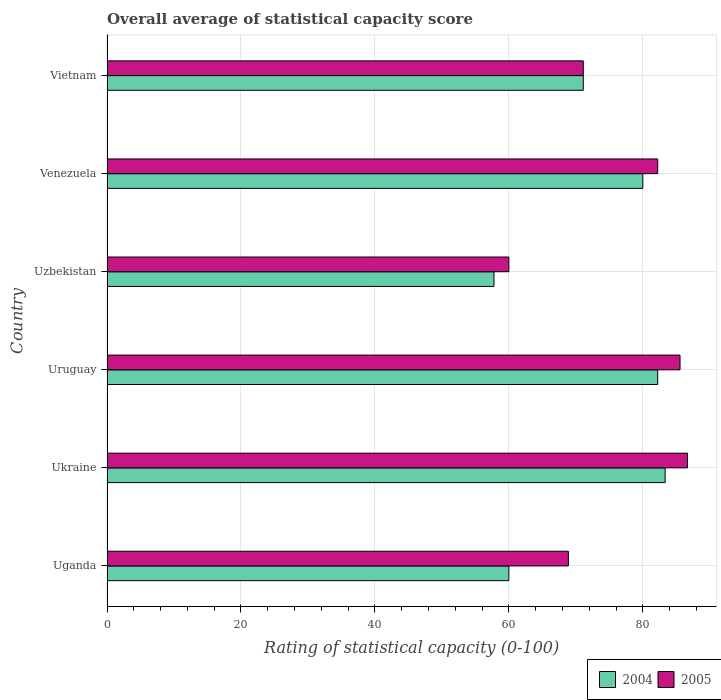Are the number of bars on each tick of the Y-axis equal?
Your answer should be very brief. Yes. How many bars are there on the 5th tick from the top?
Provide a succinct answer. 2. How many bars are there on the 2nd tick from the bottom?
Your answer should be compact. 2. What is the label of the 5th group of bars from the top?
Keep it short and to the point. Ukraine. What is the rating of statistical capacity in 2005 in Ukraine?
Offer a terse response. 86.67. Across all countries, what is the maximum rating of statistical capacity in 2004?
Make the answer very short. 83.33. In which country was the rating of statistical capacity in 2004 maximum?
Provide a succinct answer. Ukraine. In which country was the rating of statistical capacity in 2005 minimum?
Provide a short and direct response. Uzbekistan. What is the total rating of statistical capacity in 2004 in the graph?
Make the answer very short. 434.44. What is the difference between the rating of statistical capacity in 2004 in Venezuela and that in Vietnam?
Your answer should be very brief. 8.89. What is the average rating of statistical capacity in 2004 per country?
Give a very brief answer. 72.41. What is the difference between the rating of statistical capacity in 2005 and rating of statistical capacity in 2004 in Uzbekistan?
Your answer should be very brief. 2.22. What is the ratio of the rating of statistical capacity in 2005 in Ukraine to that in Venezuela?
Ensure brevity in your answer.  1.05. Is the rating of statistical capacity in 2004 in Uganda less than that in Venezuela?
Provide a succinct answer. Yes. What is the difference between the highest and the second highest rating of statistical capacity in 2005?
Give a very brief answer. 1.11. What is the difference between the highest and the lowest rating of statistical capacity in 2005?
Give a very brief answer. 26.67. Is the sum of the rating of statistical capacity in 2005 in Uruguay and Vietnam greater than the maximum rating of statistical capacity in 2004 across all countries?
Your answer should be compact. Yes. What does the 2nd bar from the top in Venezuela represents?
Provide a short and direct response. 2004. What does the 2nd bar from the bottom in Uzbekistan represents?
Your response must be concise. 2005. How many bars are there?
Your response must be concise. 12. Are all the bars in the graph horizontal?
Provide a succinct answer. Yes. How many countries are there in the graph?
Ensure brevity in your answer.  6. What is the difference between two consecutive major ticks on the X-axis?
Ensure brevity in your answer.  20. Does the graph contain grids?
Your response must be concise. Yes. Where does the legend appear in the graph?
Keep it short and to the point. Bottom right. How many legend labels are there?
Offer a very short reply. 2. What is the title of the graph?
Give a very brief answer. Overall average of statistical capacity score. Does "2013" appear as one of the legend labels in the graph?
Your answer should be compact. No. What is the label or title of the X-axis?
Offer a very short reply. Rating of statistical capacity (0-100). What is the label or title of the Y-axis?
Give a very brief answer. Country. What is the Rating of statistical capacity (0-100) of 2005 in Uganda?
Give a very brief answer. 68.89. What is the Rating of statistical capacity (0-100) in 2004 in Ukraine?
Provide a succinct answer. 83.33. What is the Rating of statistical capacity (0-100) in 2005 in Ukraine?
Give a very brief answer. 86.67. What is the Rating of statistical capacity (0-100) of 2004 in Uruguay?
Give a very brief answer. 82.22. What is the Rating of statistical capacity (0-100) of 2005 in Uruguay?
Offer a very short reply. 85.56. What is the Rating of statistical capacity (0-100) of 2004 in Uzbekistan?
Offer a very short reply. 57.78. What is the Rating of statistical capacity (0-100) of 2005 in Uzbekistan?
Your response must be concise. 60. What is the Rating of statistical capacity (0-100) in 2004 in Venezuela?
Ensure brevity in your answer.  80. What is the Rating of statistical capacity (0-100) in 2005 in Venezuela?
Provide a short and direct response. 82.22. What is the Rating of statistical capacity (0-100) of 2004 in Vietnam?
Ensure brevity in your answer.  71.11. What is the Rating of statistical capacity (0-100) of 2005 in Vietnam?
Offer a terse response. 71.11. Across all countries, what is the maximum Rating of statistical capacity (0-100) in 2004?
Give a very brief answer. 83.33. Across all countries, what is the maximum Rating of statistical capacity (0-100) in 2005?
Provide a short and direct response. 86.67. Across all countries, what is the minimum Rating of statistical capacity (0-100) of 2004?
Your answer should be very brief. 57.78. What is the total Rating of statistical capacity (0-100) in 2004 in the graph?
Provide a succinct answer. 434.44. What is the total Rating of statistical capacity (0-100) in 2005 in the graph?
Make the answer very short. 454.44. What is the difference between the Rating of statistical capacity (0-100) of 2004 in Uganda and that in Ukraine?
Provide a succinct answer. -23.33. What is the difference between the Rating of statistical capacity (0-100) in 2005 in Uganda and that in Ukraine?
Your answer should be compact. -17.78. What is the difference between the Rating of statistical capacity (0-100) of 2004 in Uganda and that in Uruguay?
Your response must be concise. -22.22. What is the difference between the Rating of statistical capacity (0-100) of 2005 in Uganda and that in Uruguay?
Give a very brief answer. -16.67. What is the difference between the Rating of statistical capacity (0-100) in 2004 in Uganda and that in Uzbekistan?
Offer a very short reply. 2.22. What is the difference between the Rating of statistical capacity (0-100) of 2005 in Uganda and that in Uzbekistan?
Make the answer very short. 8.89. What is the difference between the Rating of statistical capacity (0-100) in 2005 in Uganda and that in Venezuela?
Make the answer very short. -13.33. What is the difference between the Rating of statistical capacity (0-100) in 2004 in Uganda and that in Vietnam?
Offer a terse response. -11.11. What is the difference between the Rating of statistical capacity (0-100) in 2005 in Uganda and that in Vietnam?
Offer a very short reply. -2.22. What is the difference between the Rating of statistical capacity (0-100) of 2004 in Ukraine and that in Uzbekistan?
Your response must be concise. 25.56. What is the difference between the Rating of statistical capacity (0-100) in 2005 in Ukraine and that in Uzbekistan?
Make the answer very short. 26.67. What is the difference between the Rating of statistical capacity (0-100) of 2005 in Ukraine and that in Venezuela?
Your answer should be very brief. 4.44. What is the difference between the Rating of statistical capacity (0-100) in 2004 in Ukraine and that in Vietnam?
Ensure brevity in your answer.  12.22. What is the difference between the Rating of statistical capacity (0-100) of 2005 in Ukraine and that in Vietnam?
Offer a very short reply. 15.56. What is the difference between the Rating of statistical capacity (0-100) in 2004 in Uruguay and that in Uzbekistan?
Your answer should be compact. 24.44. What is the difference between the Rating of statistical capacity (0-100) in 2005 in Uruguay and that in Uzbekistan?
Offer a very short reply. 25.56. What is the difference between the Rating of statistical capacity (0-100) of 2004 in Uruguay and that in Venezuela?
Provide a succinct answer. 2.22. What is the difference between the Rating of statistical capacity (0-100) of 2004 in Uruguay and that in Vietnam?
Offer a terse response. 11.11. What is the difference between the Rating of statistical capacity (0-100) in 2005 in Uruguay and that in Vietnam?
Your answer should be very brief. 14.44. What is the difference between the Rating of statistical capacity (0-100) in 2004 in Uzbekistan and that in Venezuela?
Your response must be concise. -22.22. What is the difference between the Rating of statistical capacity (0-100) in 2005 in Uzbekistan and that in Venezuela?
Offer a terse response. -22.22. What is the difference between the Rating of statistical capacity (0-100) in 2004 in Uzbekistan and that in Vietnam?
Keep it short and to the point. -13.33. What is the difference between the Rating of statistical capacity (0-100) of 2005 in Uzbekistan and that in Vietnam?
Ensure brevity in your answer.  -11.11. What is the difference between the Rating of statistical capacity (0-100) in 2004 in Venezuela and that in Vietnam?
Give a very brief answer. 8.89. What is the difference between the Rating of statistical capacity (0-100) of 2005 in Venezuela and that in Vietnam?
Your answer should be compact. 11.11. What is the difference between the Rating of statistical capacity (0-100) of 2004 in Uganda and the Rating of statistical capacity (0-100) of 2005 in Ukraine?
Provide a short and direct response. -26.67. What is the difference between the Rating of statistical capacity (0-100) in 2004 in Uganda and the Rating of statistical capacity (0-100) in 2005 in Uruguay?
Keep it short and to the point. -25.56. What is the difference between the Rating of statistical capacity (0-100) in 2004 in Uganda and the Rating of statistical capacity (0-100) in 2005 in Uzbekistan?
Your response must be concise. 0. What is the difference between the Rating of statistical capacity (0-100) in 2004 in Uganda and the Rating of statistical capacity (0-100) in 2005 in Venezuela?
Make the answer very short. -22.22. What is the difference between the Rating of statistical capacity (0-100) of 2004 in Uganda and the Rating of statistical capacity (0-100) of 2005 in Vietnam?
Offer a terse response. -11.11. What is the difference between the Rating of statistical capacity (0-100) in 2004 in Ukraine and the Rating of statistical capacity (0-100) in 2005 in Uruguay?
Your answer should be very brief. -2.22. What is the difference between the Rating of statistical capacity (0-100) of 2004 in Ukraine and the Rating of statistical capacity (0-100) of 2005 in Uzbekistan?
Offer a terse response. 23.33. What is the difference between the Rating of statistical capacity (0-100) in 2004 in Ukraine and the Rating of statistical capacity (0-100) in 2005 in Vietnam?
Give a very brief answer. 12.22. What is the difference between the Rating of statistical capacity (0-100) of 2004 in Uruguay and the Rating of statistical capacity (0-100) of 2005 in Uzbekistan?
Your answer should be compact. 22.22. What is the difference between the Rating of statistical capacity (0-100) in 2004 in Uruguay and the Rating of statistical capacity (0-100) in 2005 in Vietnam?
Your response must be concise. 11.11. What is the difference between the Rating of statistical capacity (0-100) in 2004 in Uzbekistan and the Rating of statistical capacity (0-100) in 2005 in Venezuela?
Your answer should be very brief. -24.44. What is the difference between the Rating of statistical capacity (0-100) of 2004 in Uzbekistan and the Rating of statistical capacity (0-100) of 2005 in Vietnam?
Give a very brief answer. -13.33. What is the difference between the Rating of statistical capacity (0-100) in 2004 in Venezuela and the Rating of statistical capacity (0-100) in 2005 in Vietnam?
Your answer should be compact. 8.89. What is the average Rating of statistical capacity (0-100) in 2004 per country?
Keep it short and to the point. 72.41. What is the average Rating of statistical capacity (0-100) in 2005 per country?
Your response must be concise. 75.74. What is the difference between the Rating of statistical capacity (0-100) in 2004 and Rating of statistical capacity (0-100) in 2005 in Uganda?
Give a very brief answer. -8.89. What is the difference between the Rating of statistical capacity (0-100) in 2004 and Rating of statistical capacity (0-100) in 2005 in Uzbekistan?
Keep it short and to the point. -2.22. What is the difference between the Rating of statistical capacity (0-100) in 2004 and Rating of statistical capacity (0-100) in 2005 in Venezuela?
Offer a terse response. -2.22. What is the ratio of the Rating of statistical capacity (0-100) of 2004 in Uganda to that in Ukraine?
Your response must be concise. 0.72. What is the ratio of the Rating of statistical capacity (0-100) of 2005 in Uganda to that in Ukraine?
Make the answer very short. 0.79. What is the ratio of the Rating of statistical capacity (0-100) in 2004 in Uganda to that in Uruguay?
Give a very brief answer. 0.73. What is the ratio of the Rating of statistical capacity (0-100) of 2005 in Uganda to that in Uruguay?
Offer a very short reply. 0.81. What is the ratio of the Rating of statistical capacity (0-100) in 2005 in Uganda to that in Uzbekistan?
Your response must be concise. 1.15. What is the ratio of the Rating of statistical capacity (0-100) in 2004 in Uganda to that in Venezuela?
Give a very brief answer. 0.75. What is the ratio of the Rating of statistical capacity (0-100) of 2005 in Uganda to that in Venezuela?
Offer a very short reply. 0.84. What is the ratio of the Rating of statistical capacity (0-100) of 2004 in Uganda to that in Vietnam?
Your answer should be compact. 0.84. What is the ratio of the Rating of statistical capacity (0-100) in 2005 in Uganda to that in Vietnam?
Offer a terse response. 0.97. What is the ratio of the Rating of statistical capacity (0-100) in 2004 in Ukraine to that in Uruguay?
Provide a succinct answer. 1.01. What is the ratio of the Rating of statistical capacity (0-100) of 2004 in Ukraine to that in Uzbekistan?
Ensure brevity in your answer.  1.44. What is the ratio of the Rating of statistical capacity (0-100) in 2005 in Ukraine to that in Uzbekistan?
Your answer should be very brief. 1.44. What is the ratio of the Rating of statistical capacity (0-100) in 2004 in Ukraine to that in Venezuela?
Your response must be concise. 1.04. What is the ratio of the Rating of statistical capacity (0-100) of 2005 in Ukraine to that in Venezuela?
Your answer should be very brief. 1.05. What is the ratio of the Rating of statistical capacity (0-100) in 2004 in Ukraine to that in Vietnam?
Give a very brief answer. 1.17. What is the ratio of the Rating of statistical capacity (0-100) in 2005 in Ukraine to that in Vietnam?
Ensure brevity in your answer.  1.22. What is the ratio of the Rating of statistical capacity (0-100) in 2004 in Uruguay to that in Uzbekistan?
Make the answer very short. 1.42. What is the ratio of the Rating of statistical capacity (0-100) of 2005 in Uruguay to that in Uzbekistan?
Your answer should be very brief. 1.43. What is the ratio of the Rating of statistical capacity (0-100) of 2004 in Uruguay to that in Venezuela?
Offer a very short reply. 1.03. What is the ratio of the Rating of statistical capacity (0-100) in 2005 in Uruguay to that in Venezuela?
Your answer should be compact. 1.04. What is the ratio of the Rating of statistical capacity (0-100) in 2004 in Uruguay to that in Vietnam?
Provide a short and direct response. 1.16. What is the ratio of the Rating of statistical capacity (0-100) of 2005 in Uruguay to that in Vietnam?
Your response must be concise. 1.2. What is the ratio of the Rating of statistical capacity (0-100) of 2004 in Uzbekistan to that in Venezuela?
Ensure brevity in your answer.  0.72. What is the ratio of the Rating of statistical capacity (0-100) in 2005 in Uzbekistan to that in Venezuela?
Offer a terse response. 0.73. What is the ratio of the Rating of statistical capacity (0-100) of 2004 in Uzbekistan to that in Vietnam?
Your answer should be compact. 0.81. What is the ratio of the Rating of statistical capacity (0-100) of 2005 in Uzbekistan to that in Vietnam?
Provide a succinct answer. 0.84. What is the ratio of the Rating of statistical capacity (0-100) of 2005 in Venezuela to that in Vietnam?
Provide a short and direct response. 1.16. What is the difference between the highest and the lowest Rating of statistical capacity (0-100) of 2004?
Provide a succinct answer. 25.56. What is the difference between the highest and the lowest Rating of statistical capacity (0-100) in 2005?
Keep it short and to the point. 26.67. 